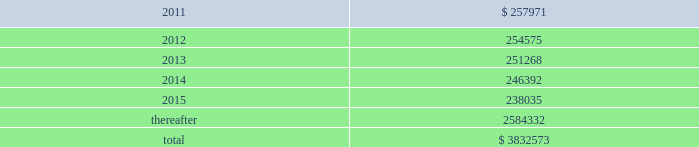American tower corporation and subsidiaries notes to consolidated financial statements mexico litigation 2014one of the company 2019s subsidiaries , spectrasite communications , inc .
( 201csci 201d ) , is involved in a lawsuit brought in mexico against a former mexican subsidiary of sci ( the subsidiary of sci was sold in 2002 , prior to the company 2019s merger with sci 2019s parent in 2005 ) .
The lawsuit concerns a terminated tower construction contract and related agreements with a wireless carrier in mexico .
The primary issue for the company is whether sci itself can be found liable to the mexican carrier .
The trial and lower appellate courts initially found that sci had no such liability in part because mexican courts do not have the necessary jurisdiction over sci .
Following several decisions by mexican appellate courts , including the supreme court of mexico , and related appeals by both parties , an intermediate appellate court issued a new decision that would , if enforceable , reimpose liability on sci in september 2010 .
In its decision , the intermediate appellate court identified potential damages of approximately $ 6.7 million , and on october 14 , 2010 , the company filed a new constitutional appeal to again dispute the decision .
As a result , at this stage of the proceeding , the company is unable to determine whether the liability imposed on sci by the september 2010 decision will survive or to estimate its share , if any , of that potential liability if the decision survives the pending appeal .
Xcel litigation 2014on june 3 , 2010 , horse-shoe capital ( 201chorse-shoe 201d ) , a company formed under the laws of the republic of mauritius , filed a complaint in the supreme court of the state of new york , new york county , with respect to horse-shoe 2019s sale of xcel to american tower mauritius ( 201catmauritius 201d ) , the company 2019s wholly-owned subsidiary formed under the laws of the republic of mauritius .
The complaint names atmauritius , ati and the company as defendants , and the dispute concerns the timing and amount of distributions to be made by atmauritius to horse-shoe from a $ 7.5 million holdback escrow account and a $ 15.7 million tax escrow account , each established by the transaction agreements at closing .
The complaint seeks release of the entire holdback escrow account , plus an additional $ 2.8 million , as well as the release of approximately $ 12.0 million of the tax escrow account .
The complaint also seeks punitive damages in excess of $ 69.0 million .
The company filed an answer to the complaint in august 2010 , disputing both the amounts alleged to be owed under the escrow agreements as well as the timing of the escrow distributions .
The company also asserted in its answer that the demand for punitive damages is meritless .
The parties have filed cross-motions for summary judgment concerning the release of the tax escrow account and in january 2011 the court granted the company 2019s motion for summary judgment , finding no obligation for the company to release the disputed portion of the tax escrow until 2013 .
Other claims are pending .
The company is vigorously defending the lawsuit .
Lease obligations 2014the company leases certain land , office and tower space under operating leases that expire over various terms .
Many of the leases contain renewal options with specified increases in lease payments upon exercise of the renewal option .
Escalation clauses present in operating leases , excluding those tied to cpi or other inflation-based indices , are recognized on a straight-line basis over the non-cancellable term of the lease .
Future minimum rental payments under non-cancellable operating leases include payments for certain renewal periods at the company 2019s option because failure to renew could result in a loss of the applicable tower site and related revenues from tenant leases , thereby making it reasonably assured that the company will renew the lease .
Such payments in effect at december 31 , 2010 are as follows ( in thousands ) : year ending december 31 .

What was the percent of the total future minimum rental payments under non-cancellable that was due in 2015? 
Computations: (238035 / 3832573)
Answer: 0.06211. 